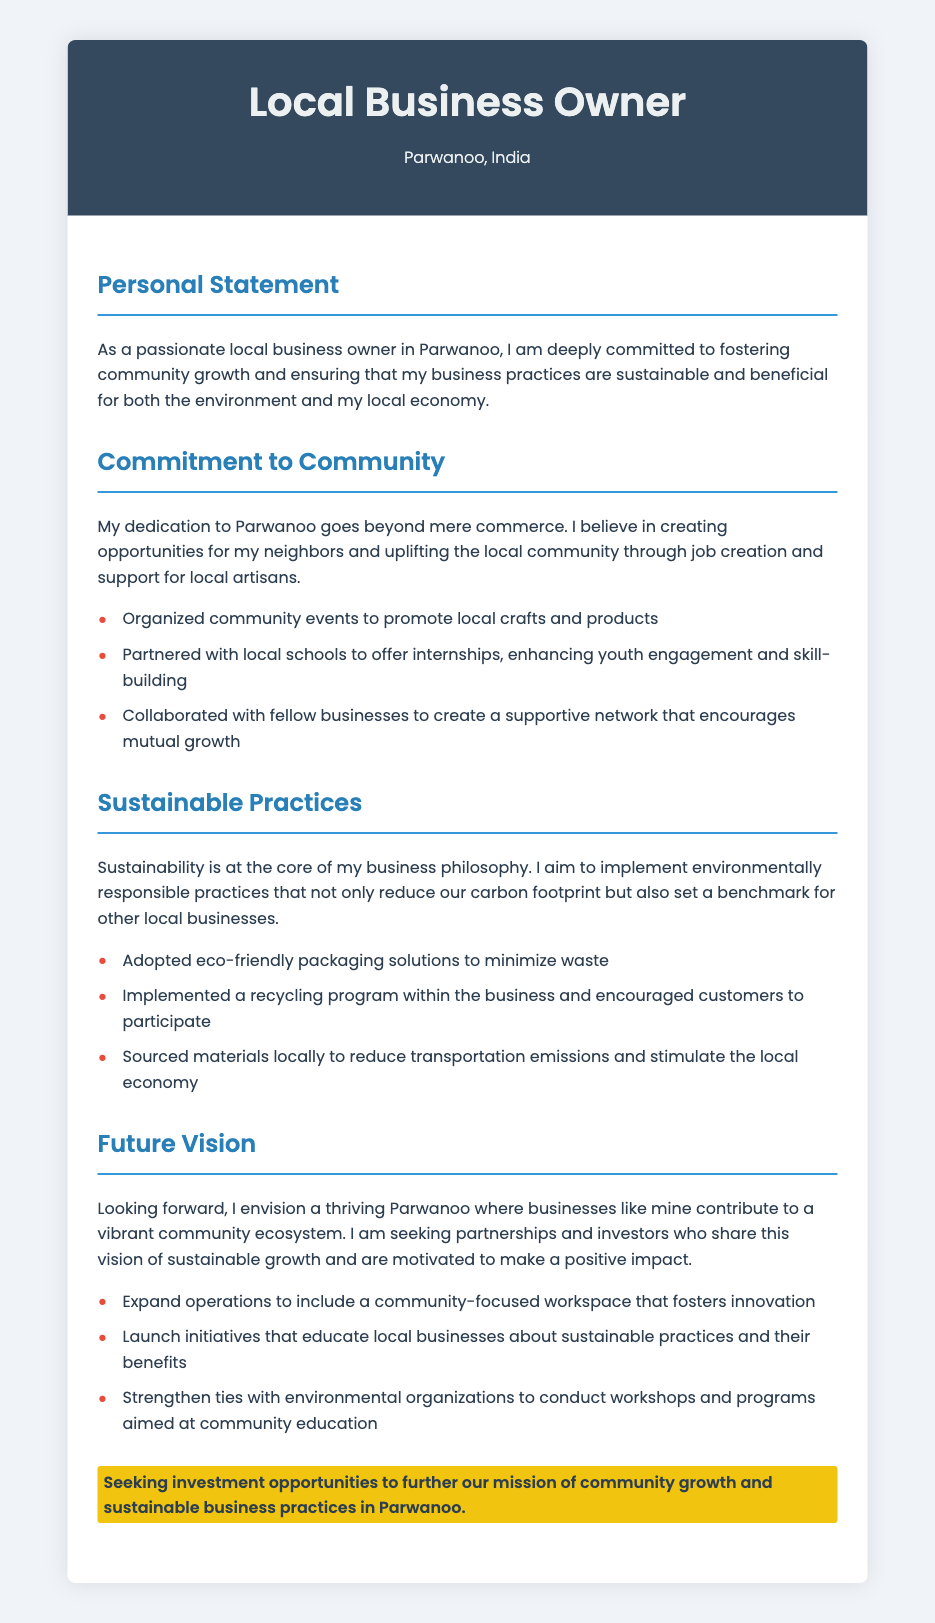What is the location of the business owner? The document states that the local business owner is located in Parwanoo, India.
Answer: Parwanoo, India What is the focus of the personal statement? The personal statement emphasizes the owner's commitment to community growth and sustainable business practices.
Answer: Community growth and sustainable business practices How many community initiatives are listed? The section on commitment to community outlines three specific initiatives.
Answer: Three What type of packaging solutions have been adopted? The document mentions the adoption of eco-friendly packaging solutions to minimize waste.
Answer: Eco-friendly packaging solutions What is the future vision for Parwanoo outlined in the document? The future vision discusses creating a thriving Parwanoo with a vibrant community ecosystem.
Answer: Thriving Parwanoo with a vibrant community ecosystem What does the owner seek in terms of investment? The document highlights the owner's interest in investment opportunities to further their mission.
Answer: Investment opportunities What collaborative effort is mentioned with local schools? The owner has partnered with local schools to offer internships for youth engagement.
Answer: Offer internships What key practice is emphasized in the sustainable practices section? The document emphasizes implementing environmentally responsible practices to reduce carbon footprint.
Answer: Environmentally responsible practices How does the owner plan to educate local businesses? The owner plans to launch initiatives that educate local businesses about sustainable practices.
Answer: Launch initiatives 